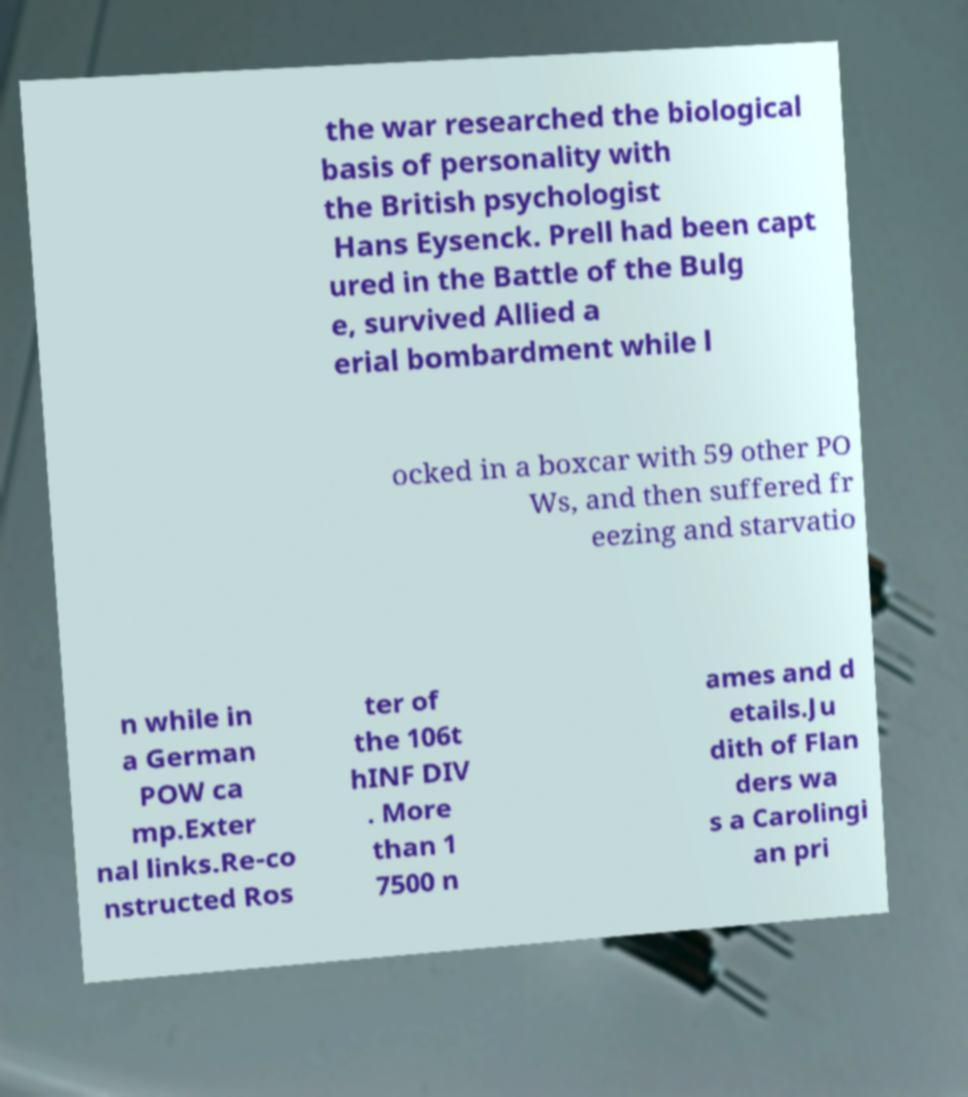Can you accurately transcribe the text from the provided image for me? the war researched the biological basis of personality with the British psychologist Hans Eysenck. Prell had been capt ured in the Battle of the Bulg e, survived Allied a erial bombardment while l ocked in a boxcar with 59 other PO Ws, and then suffered fr eezing and starvatio n while in a German POW ca mp.Exter nal links.Re-co nstructed Ros ter of the 106t hINF DIV . More than 1 7500 n ames and d etails.Ju dith of Flan ders wa s a Carolingi an pri 